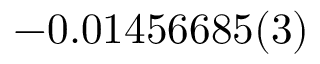Convert formula to latex. <formula><loc_0><loc_0><loc_500><loc_500>- 0 . 0 1 4 5 6 6 8 5 ( 3 )</formula> 